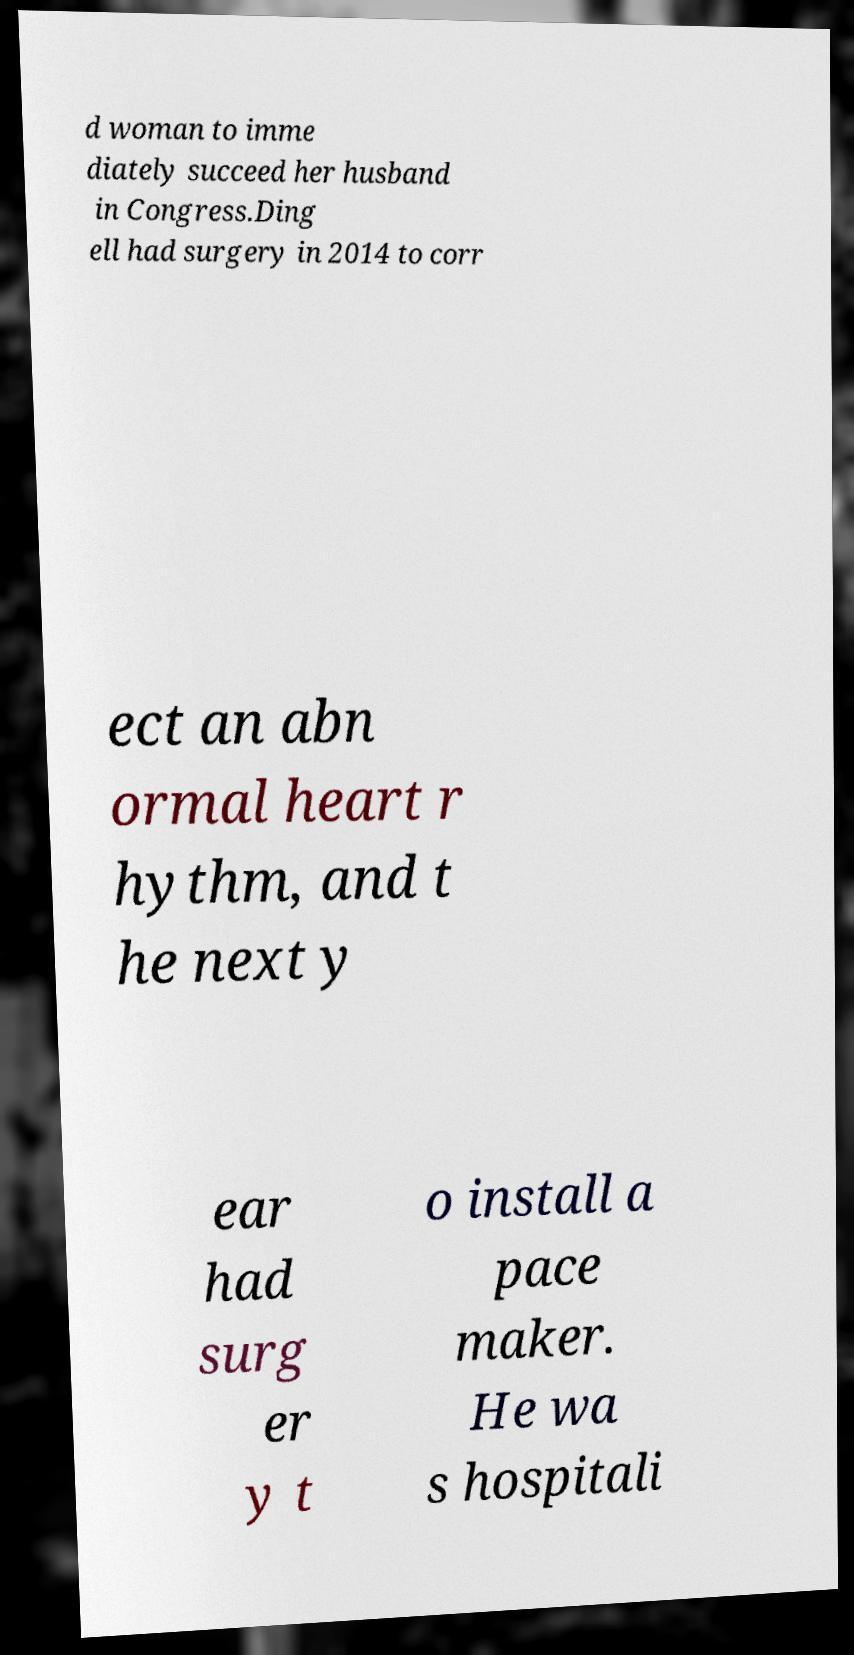For documentation purposes, I need the text within this image transcribed. Could you provide that? d woman to imme diately succeed her husband in Congress.Ding ell had surgery in 2014 to corr ect an abn ormal heart r hythm, and t he next y ear had surg er y t o install a pace maker. He wa s hospitali 